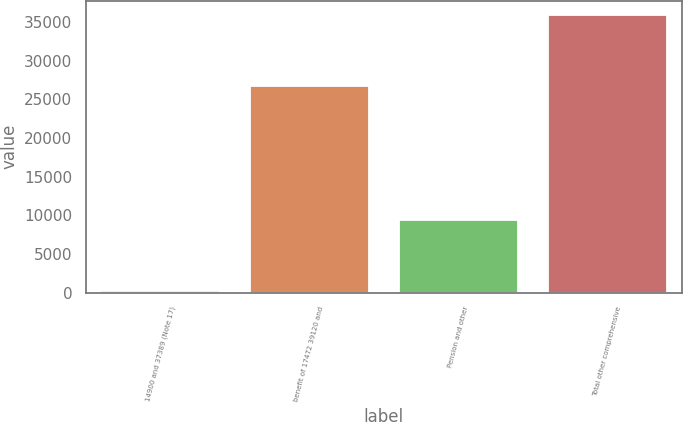<chart> <loc_0><loc_0><loc_500><loc_500><bar_chart><fcel>14900 and 37389 (Note 17)<fcel>benefit of 17472 39120 and<fcel>Pension and other<fcel>Total other comprehensive<nl><fcel>213<fcel>26747<fcel>9421<fcel>35955<nl></chart> 